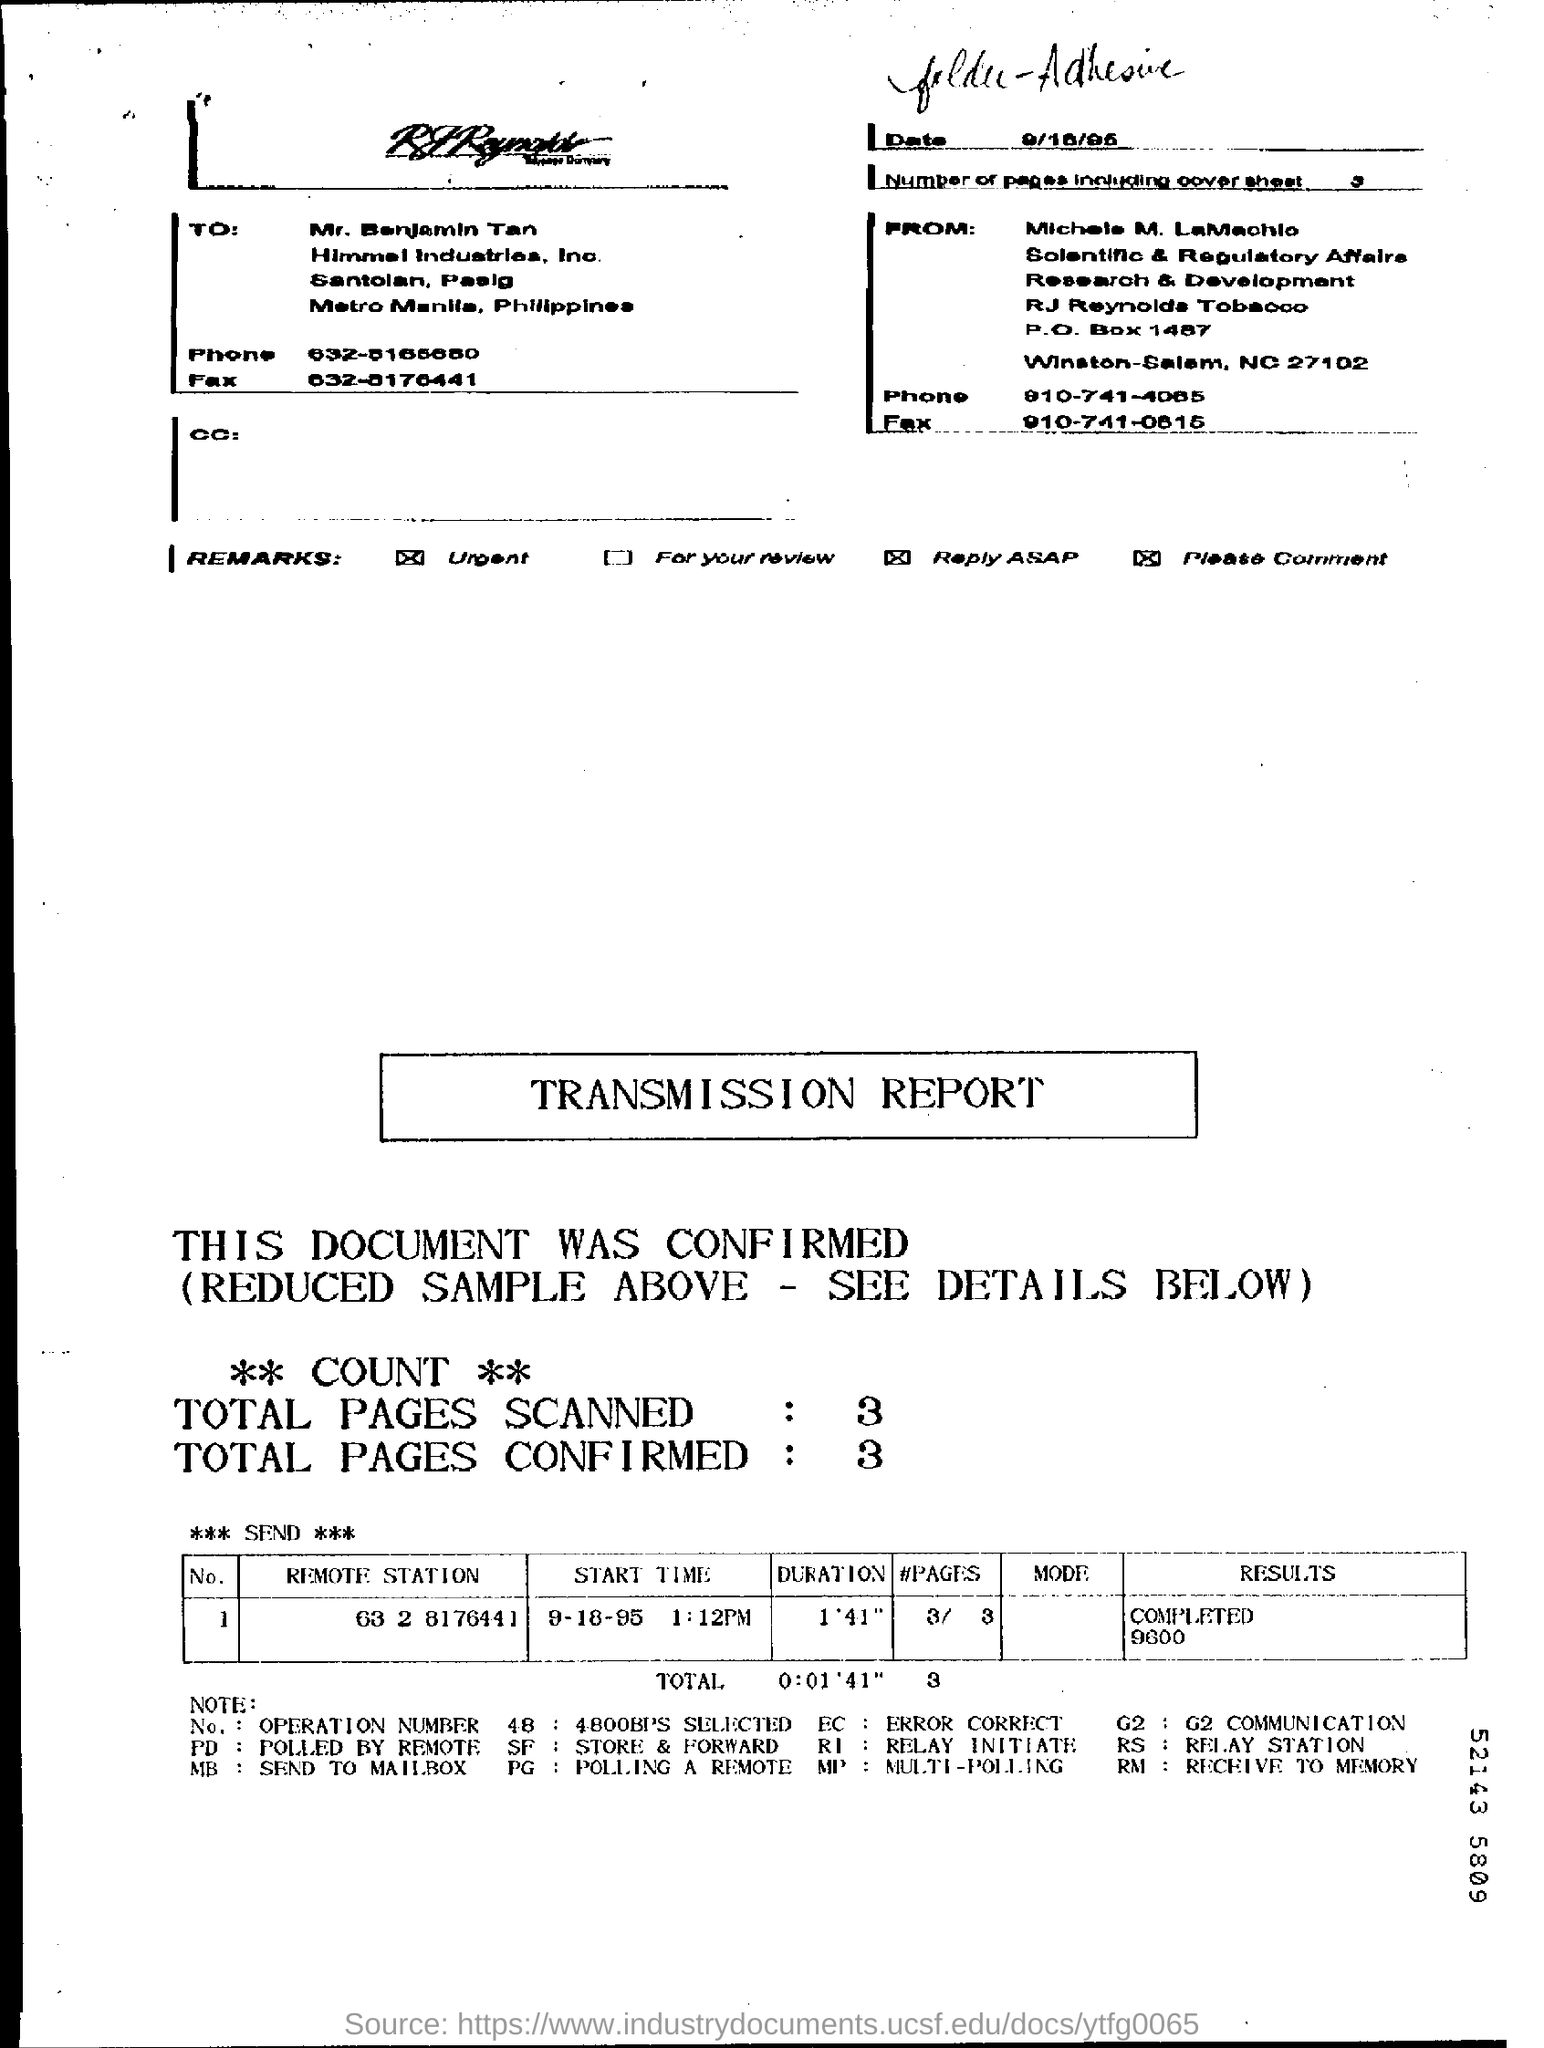What are the total number of pages CONFIRMED?
Keep it short and to the point. 3 pages. To whom is this document addressed?
Give a very brief answer. Mr. Benjamin Tan. 